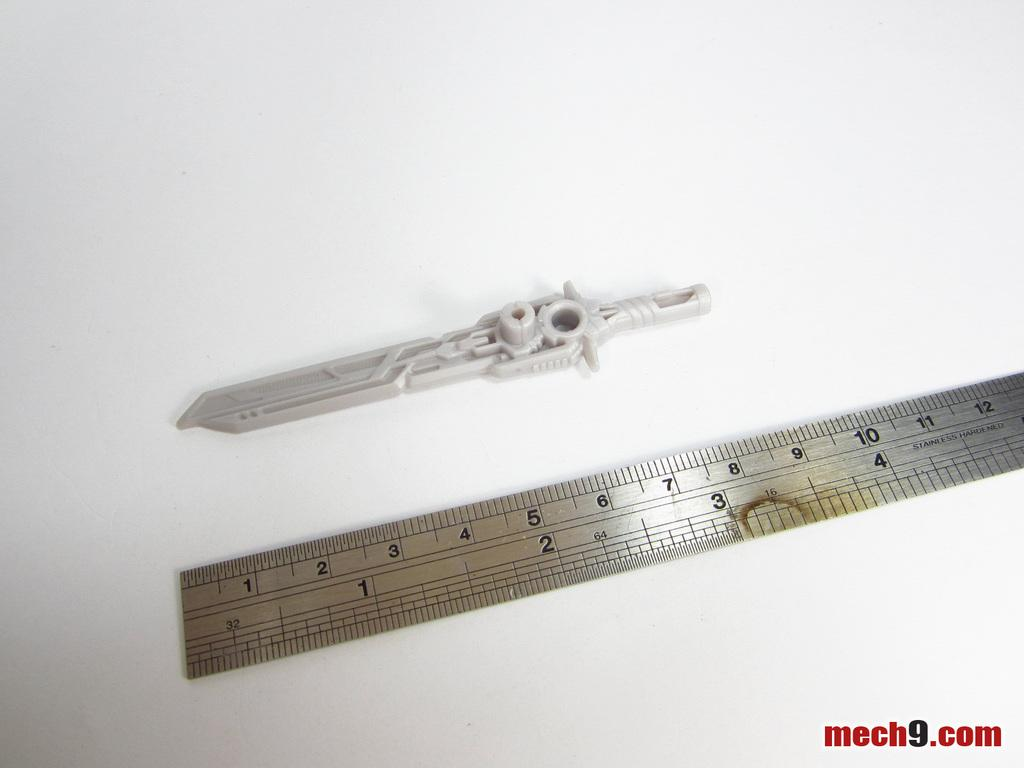<image>
Write a terse but informative summary of the picture. A ruler is displayed with mech9.com in the lower right corner. 